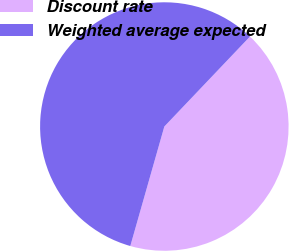Convert chart. <chart><loc_0><loc_0><loc_500><loc_500><pie_chart><fcel>Discount rate<fcel>Weighted average expected<nl><fcel>42.31%<fcel>57.69%<nl></chart> 